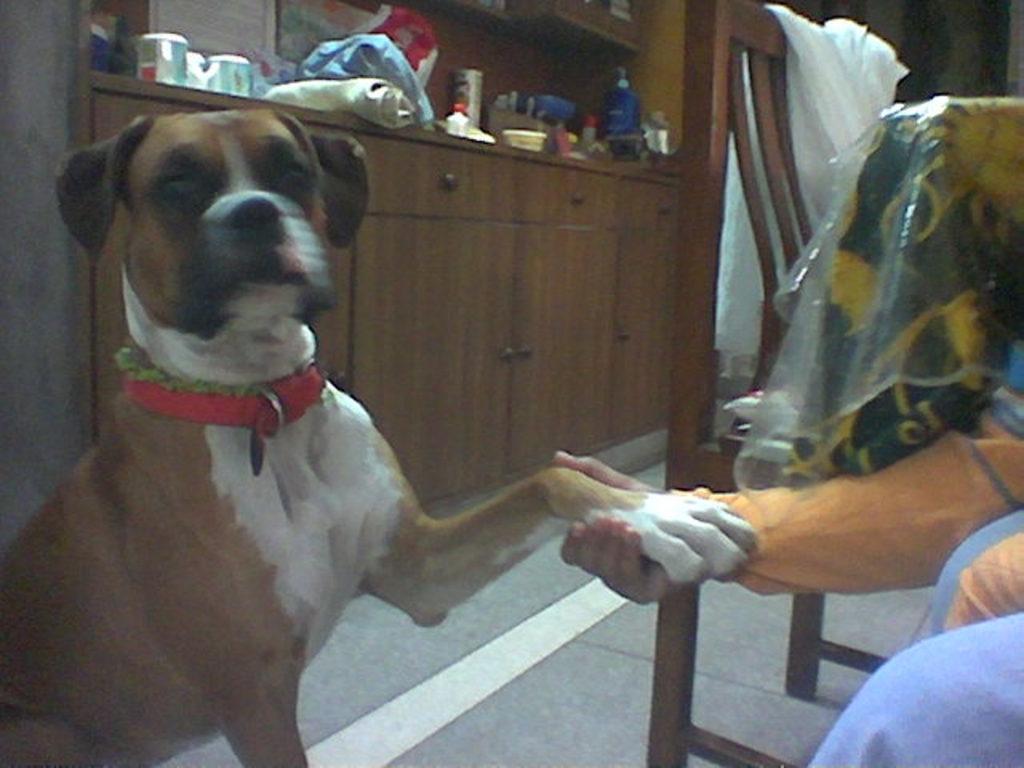Could you give a brief overview of what you see in this image? In the image we can see there is a dog sitting on the floor and a person is holding god's hand. Behind there is a wardrobe made up of wood. 